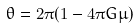<formula> <loc_0><loc_0><loc_500><loc_500>\theta = 2 \pi ( 1 - 4 \pi G \mu )</formula> 